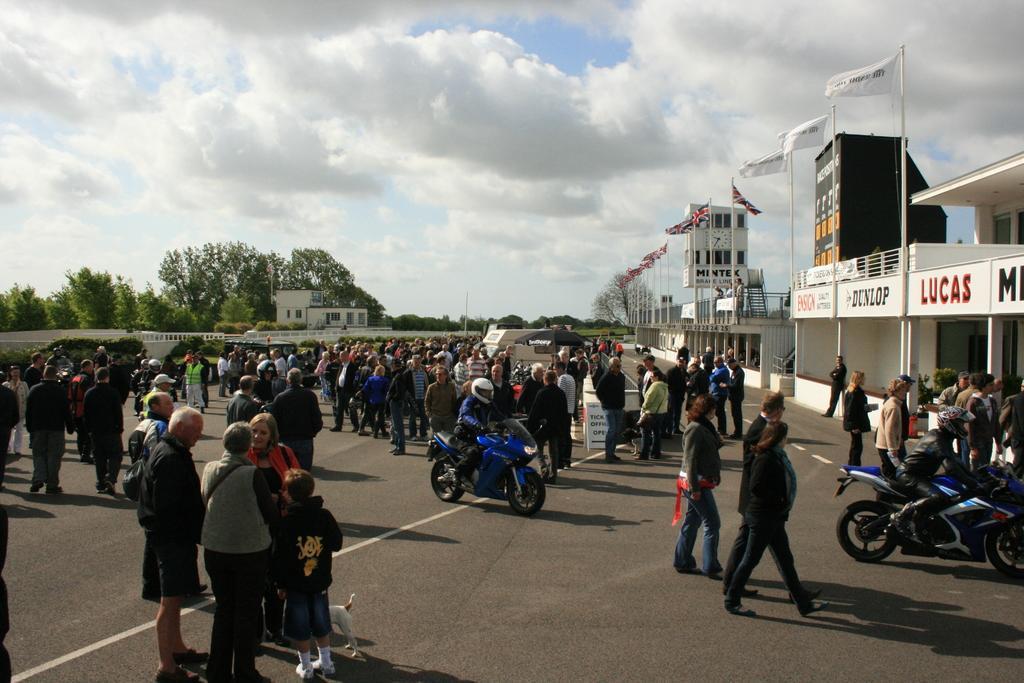Could you give a brief overview of what you see in this image? In this image there are people standing on the road. There are two people riding the bike. There is a dog. On the right side of the image there are flags. In the background of the image there are buildings, trees and sky. 